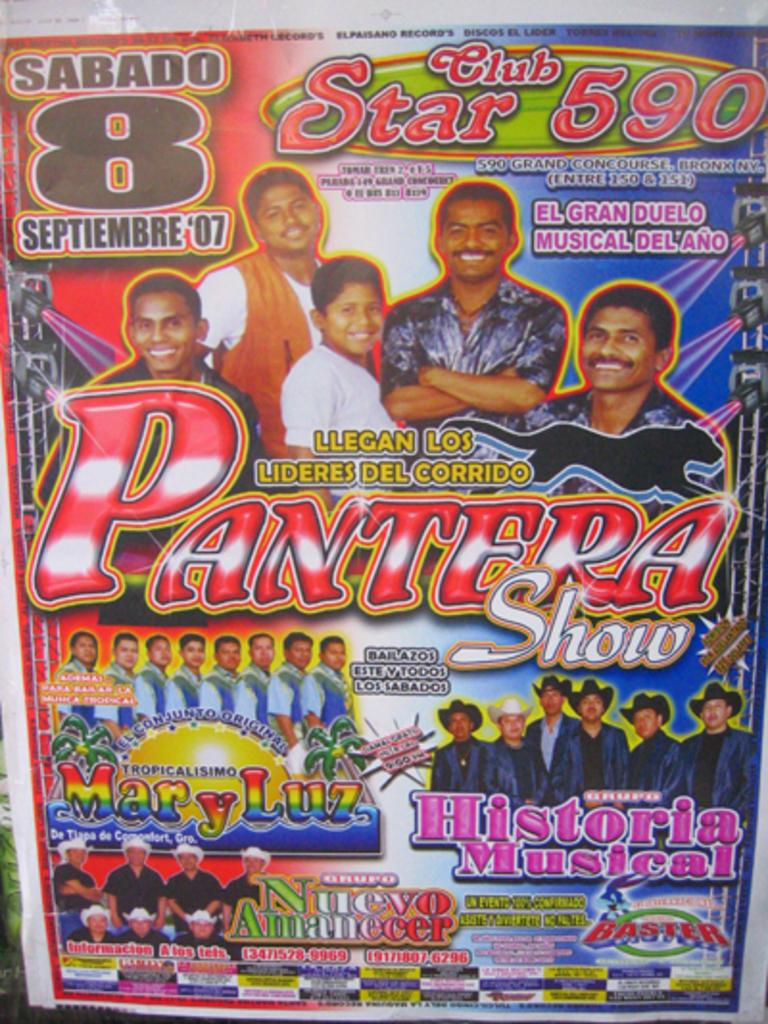What is present in the image that features images and text? There is a poster in the image that contains faces of some persons and text. Can you describe the content of the poster? The poster contains faces of some persons and text. What is the weight of the loaf depicted on the poster? There is no loaf present on the poster, so it is not possible to determine its weight. 